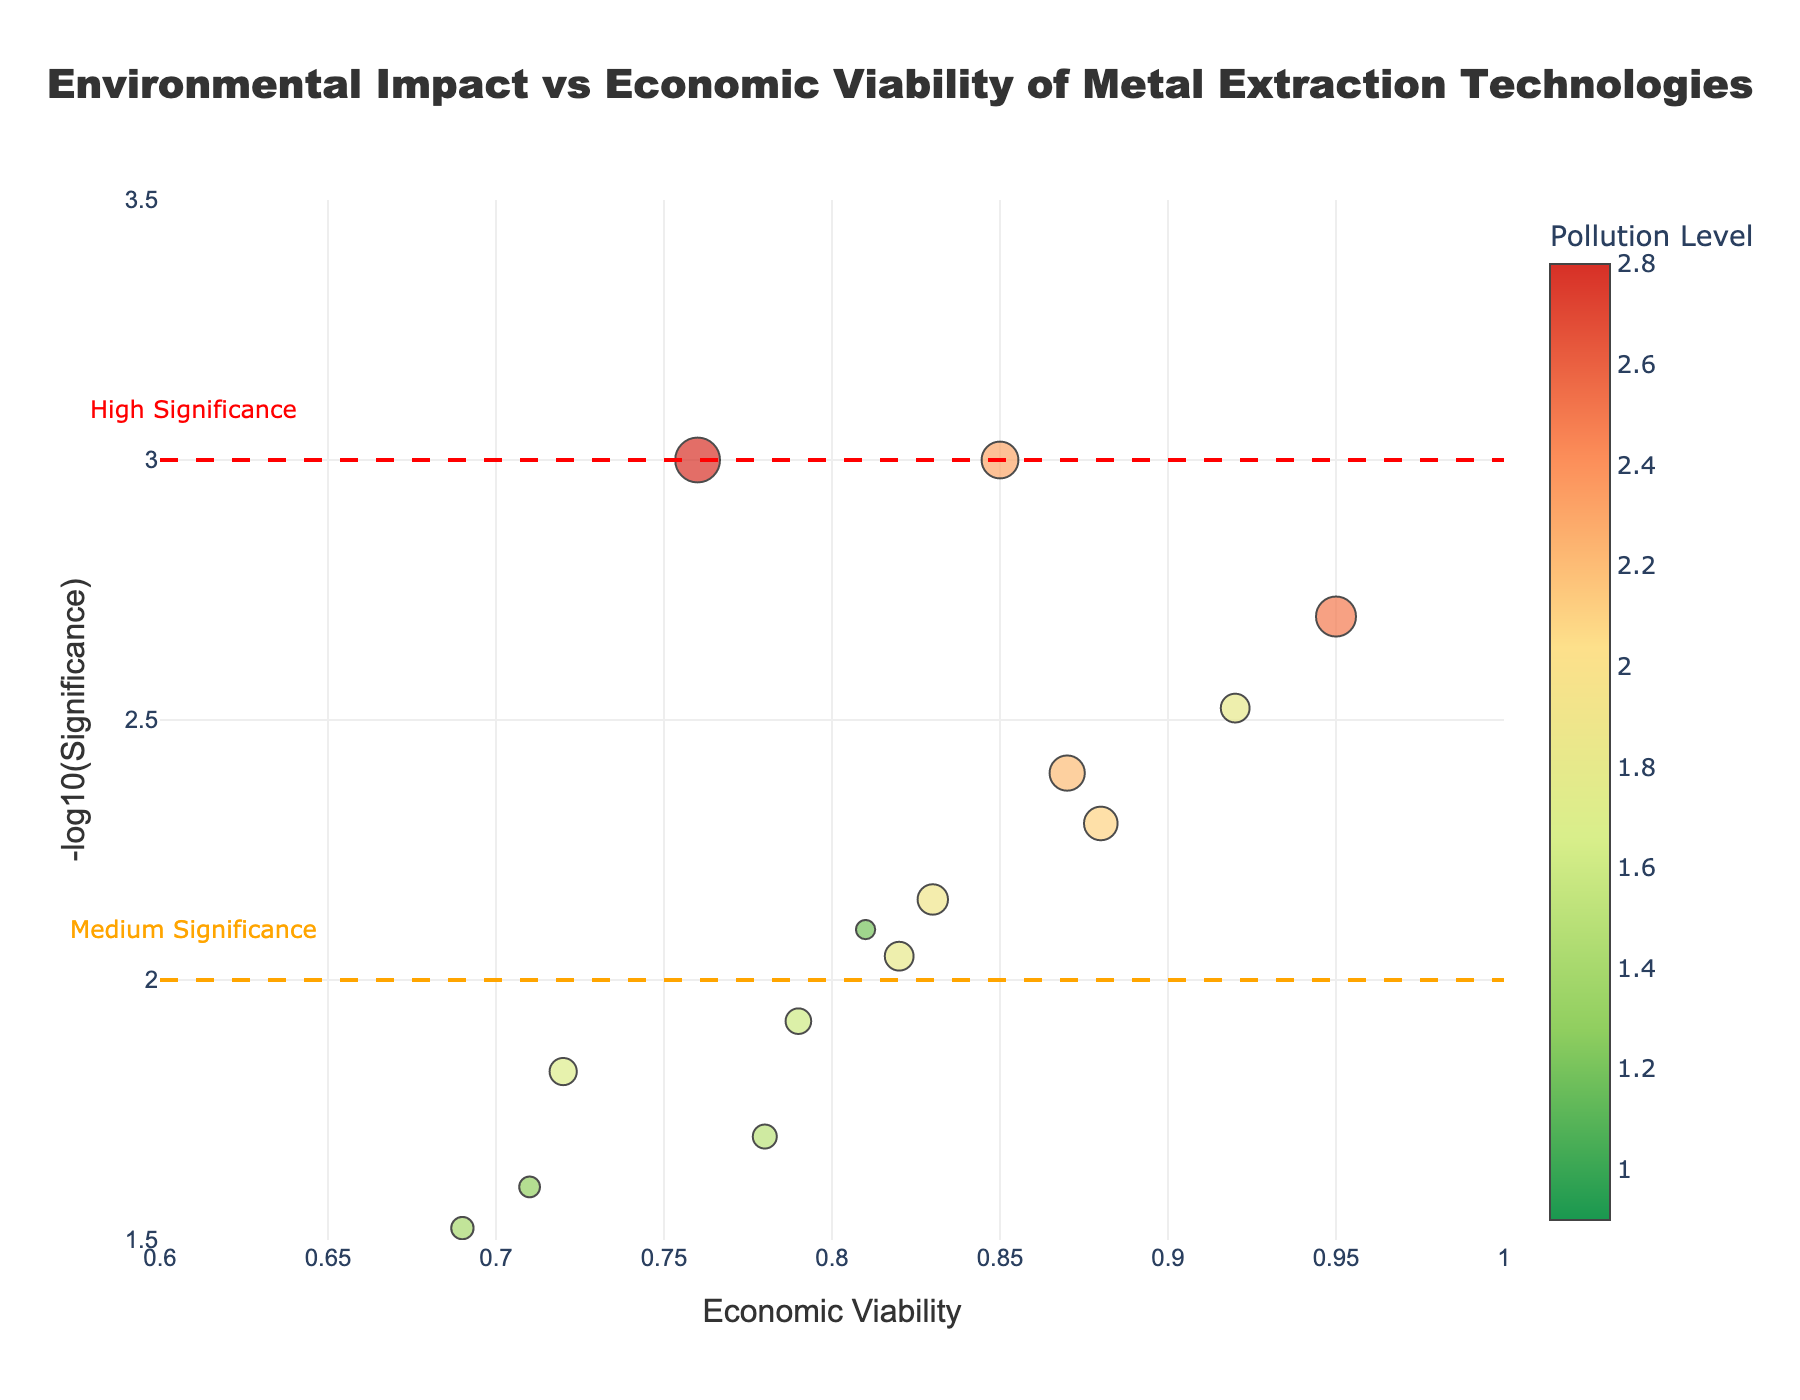What is the title of the plot? The title of the plot is located at the top center of the figure. It indicates the main subject of the chart.
Answer: Environmental Impact vs Economic Viability of Metal Extraction Technologies Which extraction method has the lowest pollution level? To identify the extraction method with the lowest pollution level, check the color of the markers, where the numerical representation of pollution levels is indicated on the color bar. The smallest pollution level corresponds to the least intense color.
Answer: Bioleaching Nickel How many extraction methods have a pollution level higher than 2? Look for markers with colors indicating pollution levels higher than 2, according to the color scale shown in the color bar on the right side of the plot.
Answer: 6 methods Which extraction method has the highest -log10(Significance)? The -log10(Significance) value is plotted on the y-axis (vertical). The point highest along this axis identifies the method with the highest -log10(Significance).
Answer: Pyrometallurgy Copper and Smelting Lead Compare the economic viability and pollution level of Hydrometallurgy Gold and Cyanidation Silver. Which one is more economically viable and which one has a higher pollution level? Check the positions of the markers for both methods: 
- Hydrometallurgy Gold: Economic Viability (x-axis) around 0.92, Pollution Level indicated by the marker's color.
- Cyanidation Silver: Economic Viability around 0.95, Pollution Level also indicated by the color.
Compare these values to find which method is higher on each characteristic.
Answer: Cyanidation Silver is more economically viable and has a higher pollution level What are the thresholds for high and medium significance, and how are they represented in the plot? The thresholds for significance are indicated by lines drawn at certain y-axis values. Reference the captions and lines:
- High Significance threshold is represented by a dashed red line at y = 3.
- Medium Significance threshold is represented by a dashed orange line at y = 2.
Answer: High: y = 3, Medium: y = 2 Which extraction method has the highest pollution level among those with an economic viability above 0.8? Look at the methods above the economic viability value of 0.8 on the x-axis, then compare their pollution levels. The highest pollution level can be identified by the marker's color (darker color indicates higher pollution).
Answer: Cyanidation Silver Which extraction methods fall above the high significance threshold? Identify markers positioned above the red dashed line representing high significance, which is at y = 3 on the y-axis.
Answer: Pyrometallurgy Copper and Smelting Lead Which method is more significant (lower p-value), Electrometallurgy Aluminum or In-Situ Leaching Uranium? Compare their positions on the y-axis (-log10(Significance)): 
- Electrometallurgy Aluminum: y value around 1.7.
- In-Situ Leaching Uranium: y value around 2.2.
A higher y value indicates a lower p-value (more significant).
Answer: In-Situ Leaching Uranium 